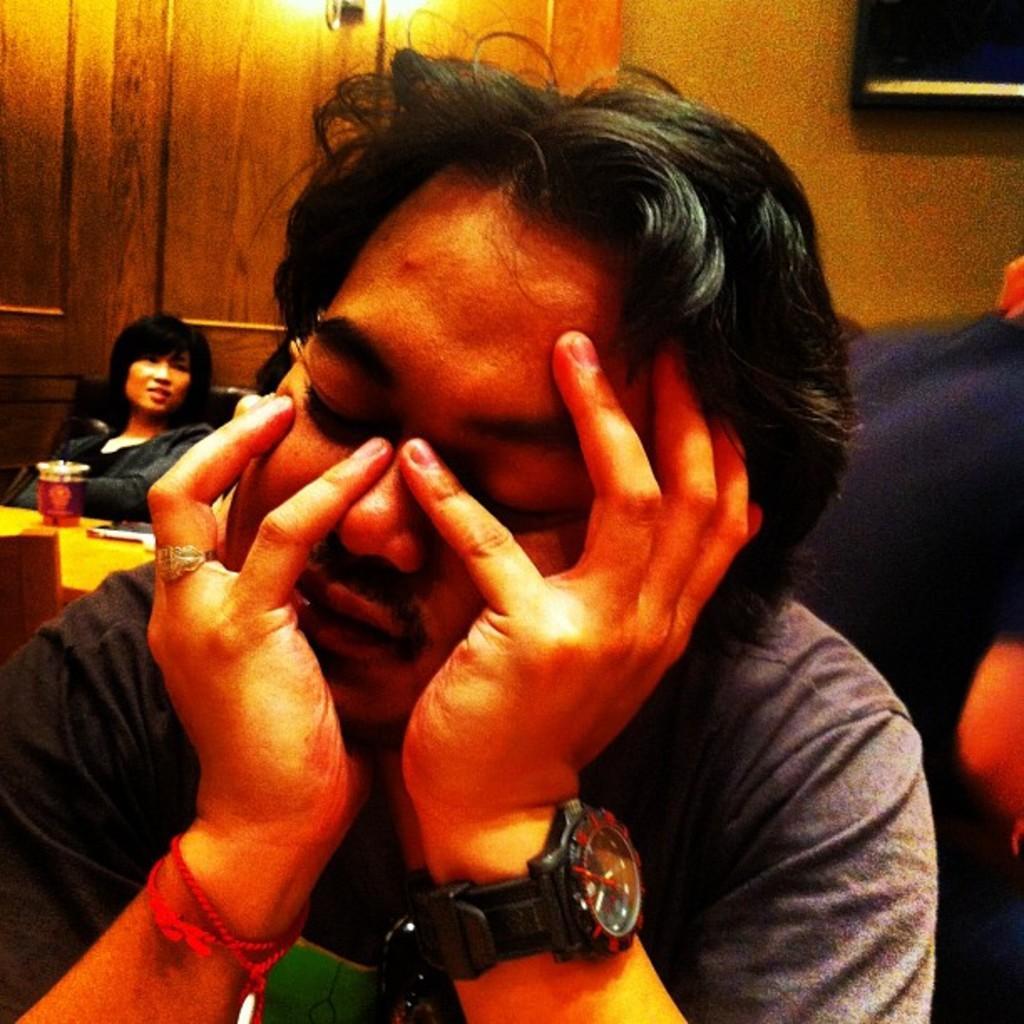In one or two sentences, can you explain what this image depicts? In this image I can see a person in the foreground wearing a watch, in the background I can see a person sitting and a glass on the table. 